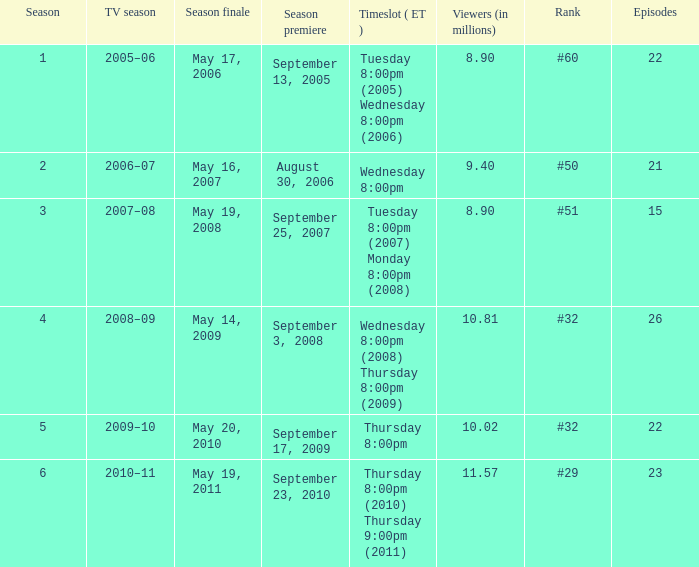How many seasons was the rank equal to #50? 1.0. Could you parse the entire table as a dict? {'header': ['Season', 'TV season', 'Season finale', 'Season premiere', 'Timeslot ( ET )', 'Viewers (in millions)', 'Rank', 'Episodes'], 'rows': [['1', '2005–06', 'May 17, 2006', 'September 13, 2005', 'Tuesday 8:00pm (2005) Wednesday 8:00pm (2006)', '8.90', '#60', '22'], ['2', '2006–07', 'May 16, 2007', 'August 30, 2006', 'Wednesday 8:00pm', '9.40', '#50', '21'], ['3', '2007–08', 'May 19, 2008', 'September 25, 2007', 'Tuesday 8:00pm (2007) Monday 8:00pm (2008)', '8.90', '#51', '15'], ['4', '2008–09', 'May 14, 2009', 'September 3, 2008', 'Wednesday 8:00pm (2008) Thursday 8:00pm (2009)', '10.81', '#32', '26'], ['5', '2009–10', 'May 20, 2010', 'September 17, 2009', 'Thursday 8:00pm', '10.02', '#32', '22'], ['6', '2010–11', 'May 19, 2011', 'September 23, 2010', 'Thursday 8:00pm (2010) Thursday 9:00pm (2011)', '11.57', '#29', '23']]} 